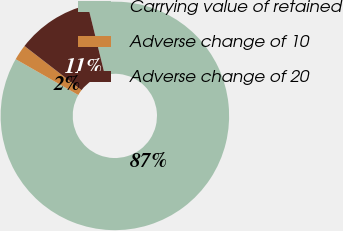Convert chart to OTSL. <chart><loc_0><loc_0><loc_500><loc_500><pie_chart><fcel>Carrying value of retained<fcel>Adverse change of 10<fcel>Adverse change of 20<nl><fcel>87.09%<fcel>2.21%<fcel>10.7%<nl></chart> 